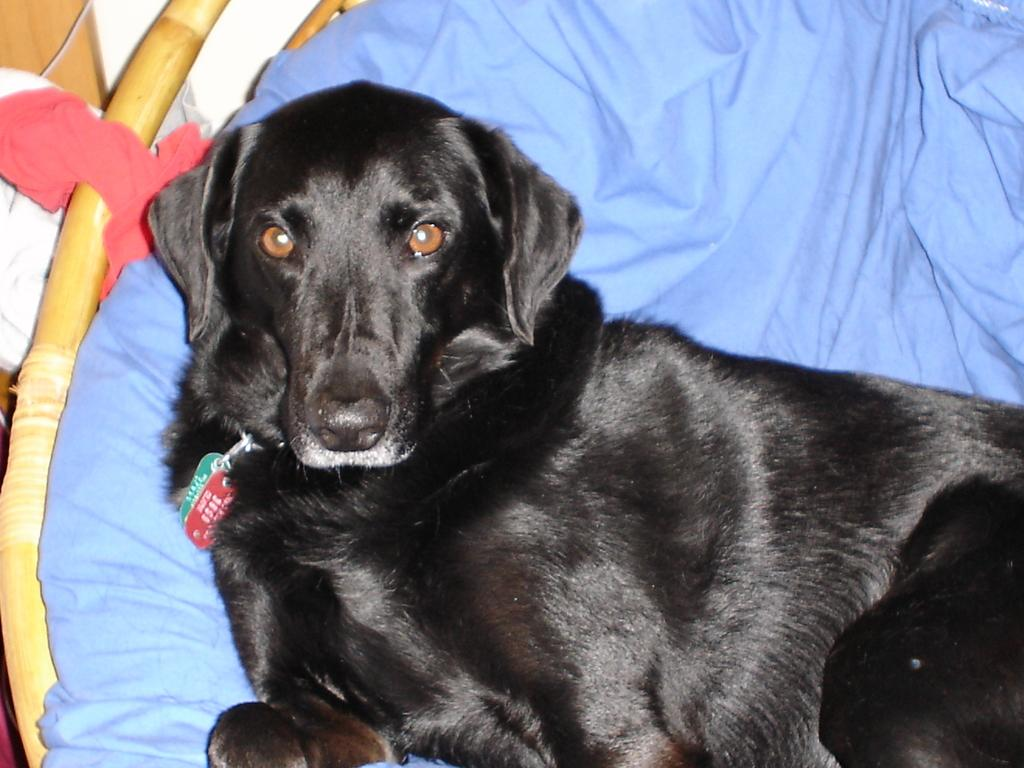What animal is present in the image? There is a dog in the image. What is the color of the dog? The dog is black in color. Where is the dog located in the image? The dog is sitting on a couch. What type of quarter is being used by the dog on the stage in the image? There is no quarter or stage present in the image; it features a black dog sitting on a couch. 